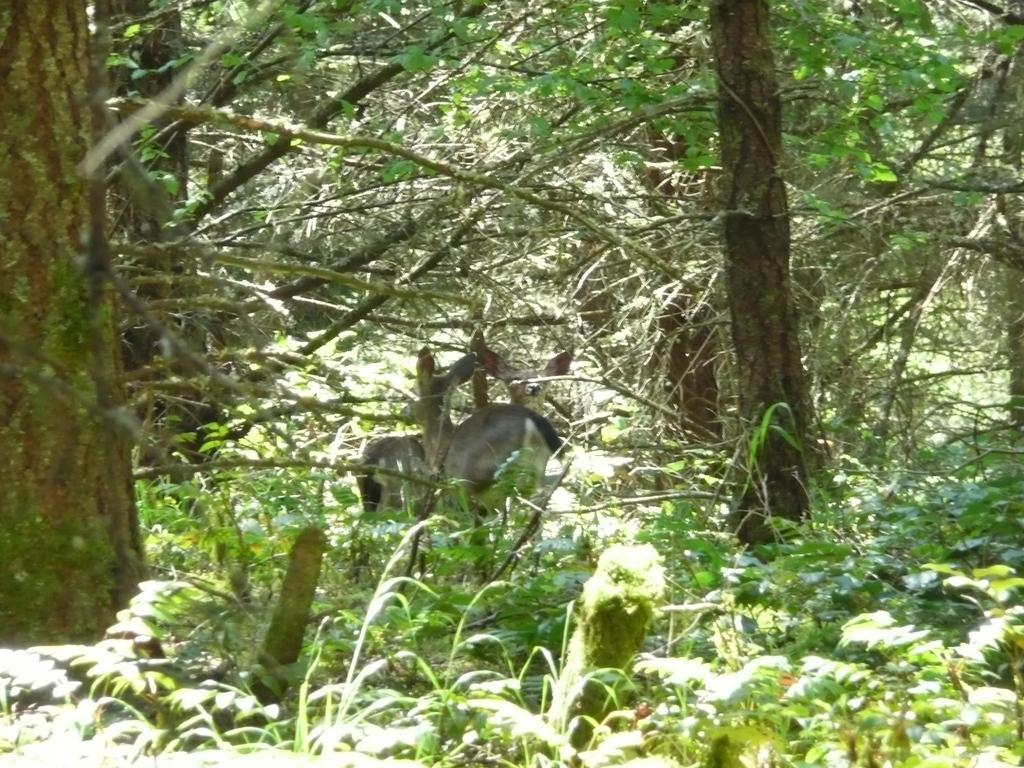Could you give a brief overview of what you see in this image? In this picture we can see there are two animals on the path and behind the animals there are trees and plants. 